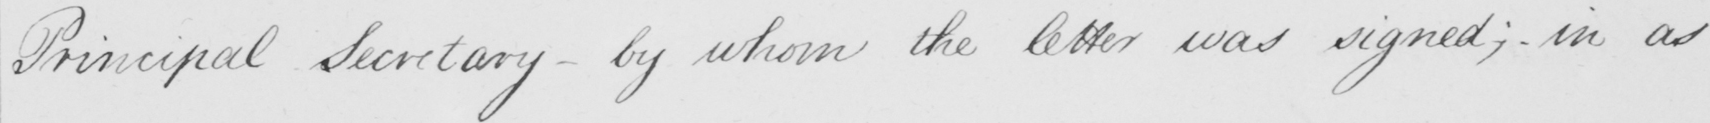Can you read and transcribe this handwriting? Principal Secretary  _  by whom the letter was signed ; in as 